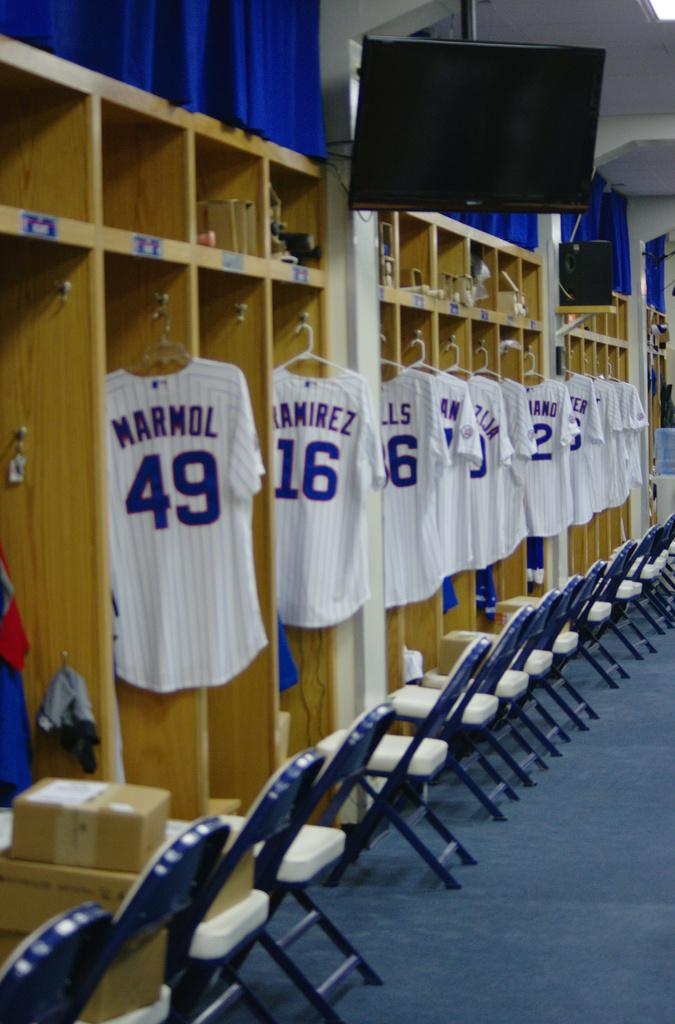<image>
Give a short and clear explanation of the subsequent image. Baseball player jerseys line the locker room including one for Marmol who wears number 49. 